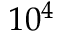<formula> <loc_0><loc_0><loc_500><loc_500>1 0 ^ { 4 }</formula> 